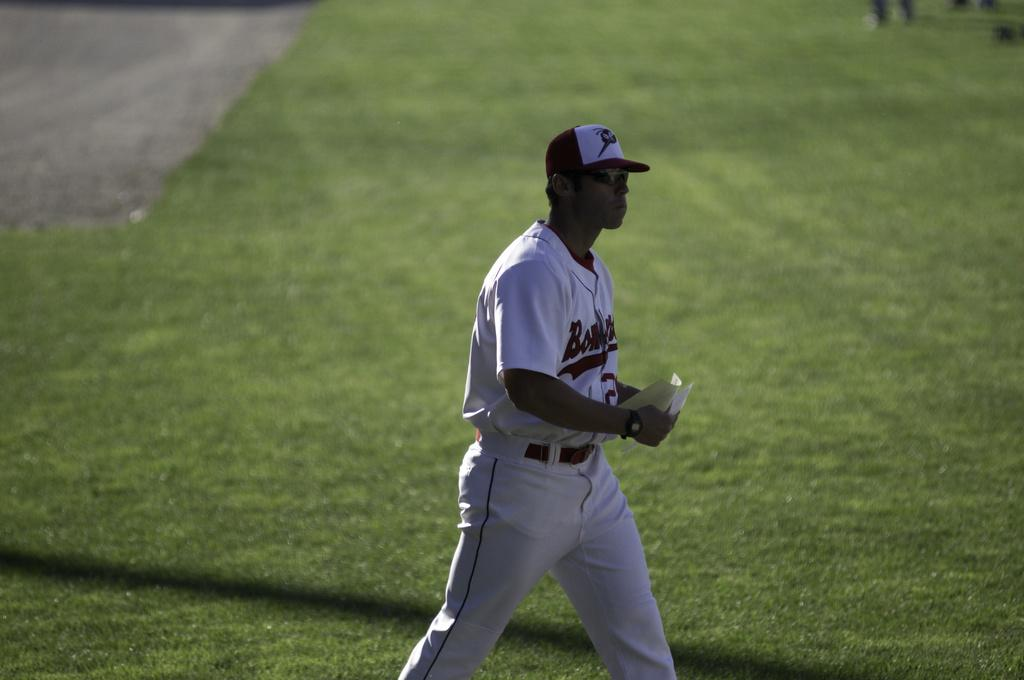Provide a one-sentence caption for the provided image. The baseball player had an outfit that starts with the letters "Bom". 